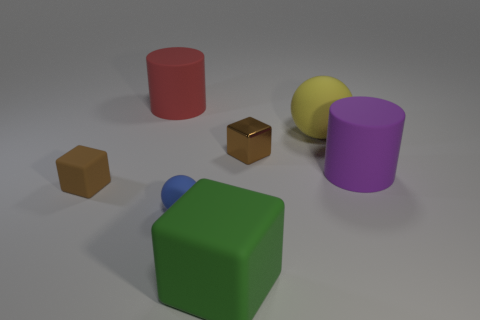Do the tiny rubber ball and the big rubber ball have the same color?
Offer a very short reply. No. There is a tiny thing that is behind the brown matte block; is there a yellow thing in front of it?
Keep it short and to the point. No. What number of things are rubber things behind the small brown shiny object or rubber spheres that are on the left side of the large yellow matte object?
Provide a short and direct response. 3. How many objects are either yellow rubber objects or cubes behind the big green rubber object?
Keep it short and to the point. 3. There is a sphere that is in front of the brown cube that is to the right of the small brown cube that is to the left of the blue rubber ball; what is its size?
Give a very brief answer. Small. What material is the other brown object that is the same size as the brown matte object?
Provide a short and direct response. Metal. Are there any rubber cubes of the same size as the purple matte cylinder?
Provide a short and direct response. Yes. There is a brown block to the left of the green matte thing; is it the same size as the big green block?
Your answer should be very brief. No. What is the shape of the small object that is right of the red rubber cylinder and in front of the purple cylinder?
Your answer should be very brief. Sphere. Are there more big purple matte objects that are in front of the blue object than green rubber blocks?
Make the answer very short. No. 